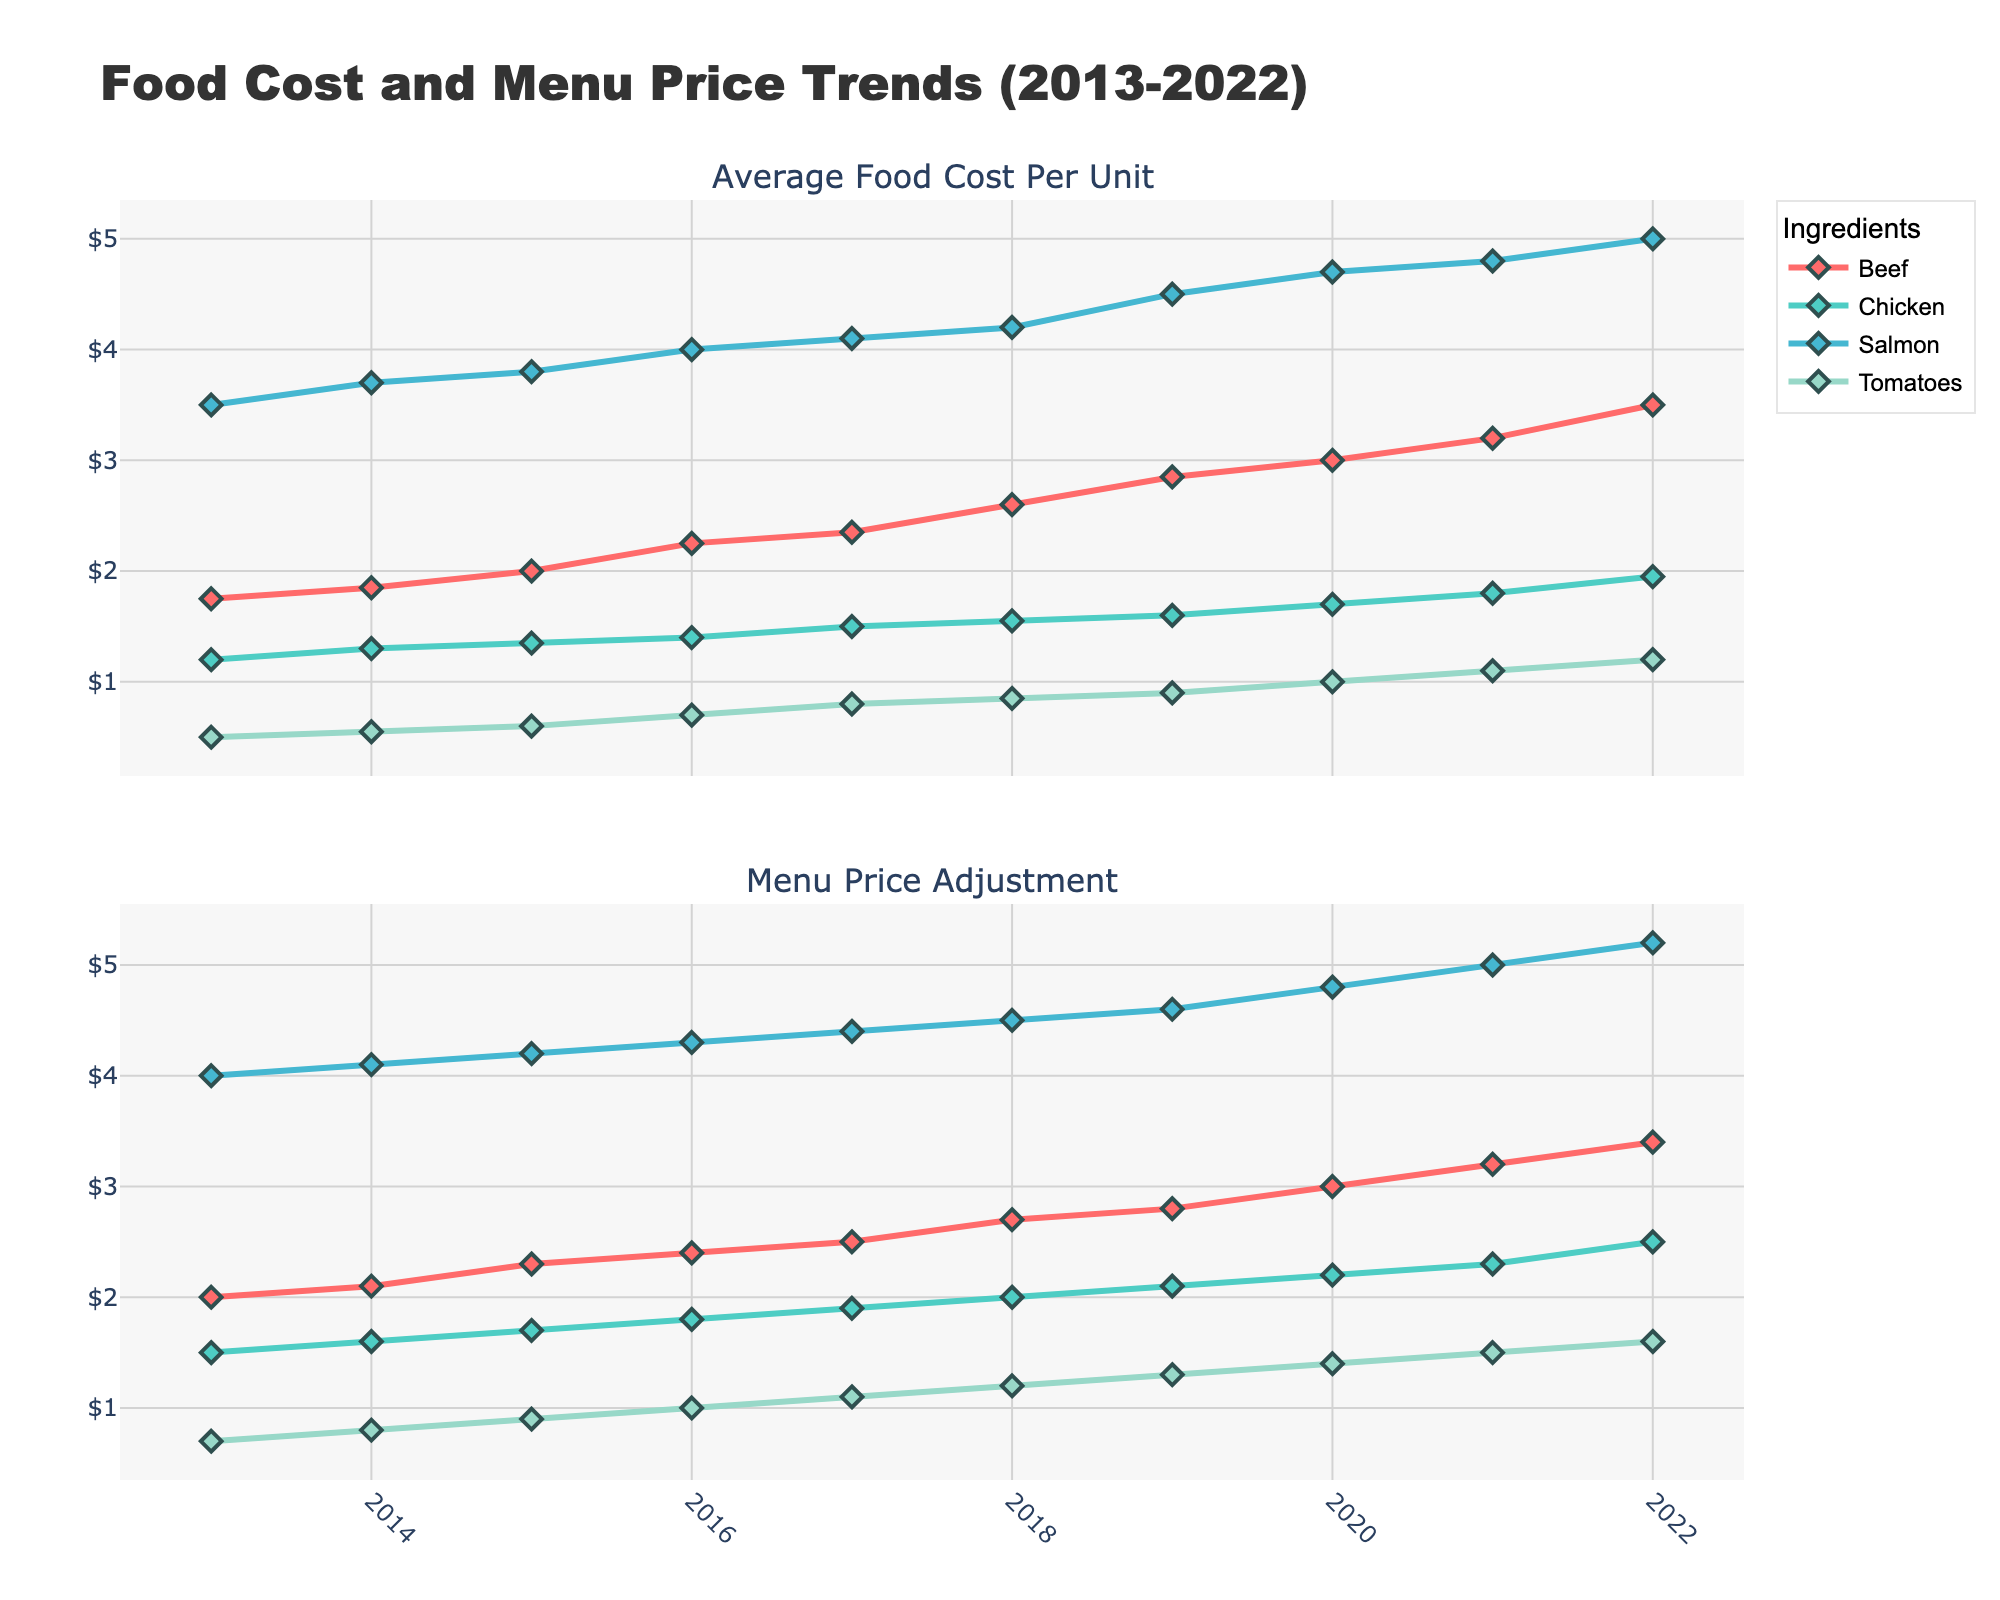What is the color used for the Salmon data line? The Salmon data line is represented by a unique color in the plot. By referring to the legend, we can identify that the Salmon line is in a shade of blue.
Answer: Blue How much did the average food cost per unit for Beef change from 2013 to 2022? To find the change in average food cost per unit for Beef between 2013 and 2022, subtract the 2013 value from the 2022 value. The cost in 2013 was $1.75, and in 2022 it was $3.50. The change is $3.50 - $1.75 = $1.75.
Answer: $1.75 Which ingredient has the highest menu price adjustment in 2022? The menu price adjustments for the year 2022 can be found on the second subplot. By referring to the values, we see that Salmon has the highest menu price adjustment in 2022 at $5.20.
Answer: Salmon Did the average food cost per unit for Tomatoes ever exceed $1.00 between 2013 and 2022? The average food cost per unit for Tomatoes can be tracked on the first subplot over the years. Observing the data points, we see that from 2020 onwards, the cost exceeds $1.00, reaching $1.00 in 2020, $1.10 in 2021, and $1.20 in 2022.
Answer: Yes By how much did the menu price adjustment for Chicken increase from 2015 to 2020? To determine the increase, subtract the menu price in 2015 from the menu price in 2020. In 2015, the adjustment was $1.70, and in 2020 it was $2.20. Hence, the increase is $2.20 - $1.70 = $0.50.
Answer: $0.50 What was the trend of the average food cost per unit for Salmon between 2013 and 2022? Observing the first subplot, we can see the trend line for Salmon, which consistently increases from 2013 ($3.50) to 2022 ($5.00). This indicates a steady upward trend over the years.
Answer: Upward trend Which year saw the highest increase in menu price adjustment for Beef? To identify the year with the highest increase, calculate the annual changes in Beef's menu price adjustment from the second subplot. The increase from 2015 to 2016 is the highest, with $2.4 - $2.3 = $0.10.
Answer: 2016 How does the menu price adjustment for Tomatoes in 2013 compare to that in 2018? Comparing the menu price adjustments for Tomatoes between 2013 and 2018, from the second subplot, we note the values are $0.70 in 2013 and $1.20 in 2018. Therefore, the menu price adjustment increased by $1.20 - $0.70 = $0.50.
Answer: Increased by $0.50 Which ingredient had the smallest increase in average food cost per unit over the decade? To find the ingredient with the smallest increase, calculate the increase for each ingredient from 2013 to 2022. Beef increased by $1.75, Chicken by $0.75, Salmon by $1.50, and Tomatoes by $0.70. Tomatoes had the smallest increase of $0.70.
Answer: Tomatoes Did any ingredient have a menu price adjustment that remained the same for consecutive years? Reviewing the second subplot for all ingredients, it is observed that all menu price adjustments increased each year, and none remained the same for consecutive years.
Answer: No 